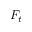Convert formula to latex. <formula><loc_0><loc_0><loc_500><loc_500>F _ { t }</formula> 